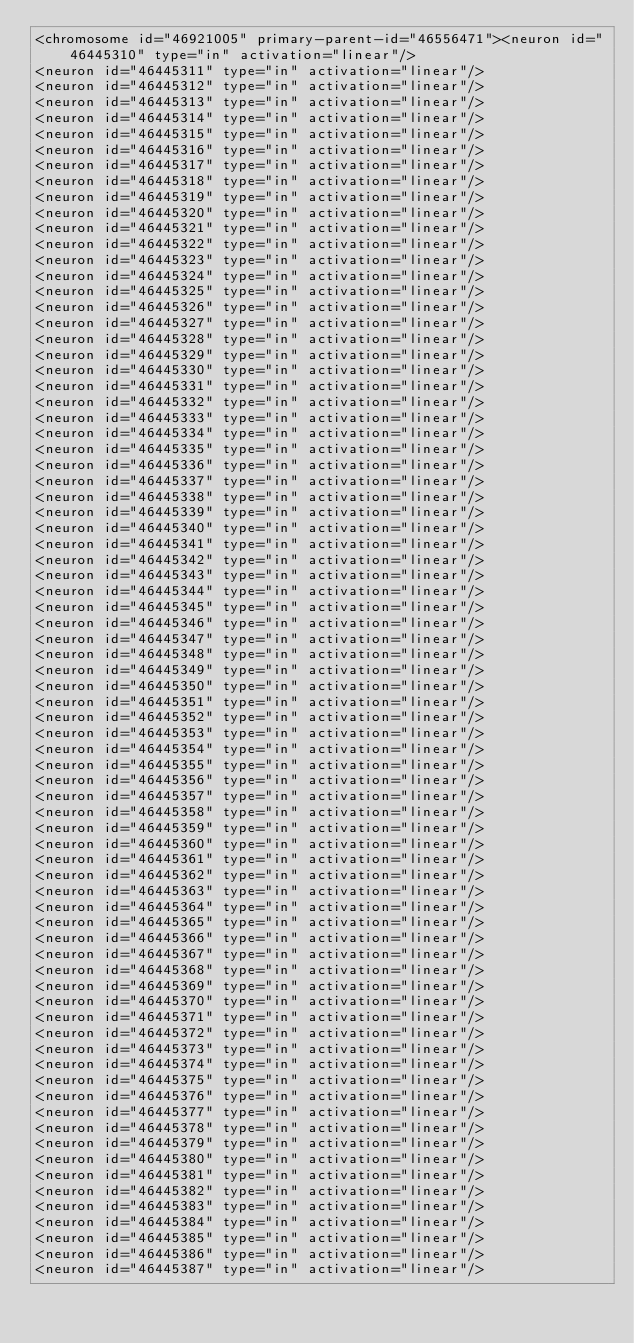Convert code to text. <code><loc_0><loc_0><loc_500><loc_500><_XML_><chromosome id="46921005" primary-parent-id="46556471"><neuron id="46445310" type="in" activation="linear"/>
<neuron id="46445311" type="in" activation="linear"/>
<neuron id="46445312" type="in" activation="linear"/>
<neuron id="46445313" type="in" activation="linear"/>
<neuron id="46445314" type="in" activation="linear"/>
<neuron id="46445315" type="in" activation="linear"/>
<neuron id="46445316" type="in" activation="linear"/>
<neuron id="46445317" type="in" activation="linear"/>
<neuron id="46445318" type="in" activation="linear"/>
<neuron id="46445319" type="in" activation="linear"/>
<neuron id="46445320" type="in" activation="linear"/>
<neuron id="46445321" type="in" activation="linear"/>
<neuron id="46445322" type="in" activation="linear"/>
<neuron id="46445323" type="in" activation="linear"/>
<neuron id="46445324" type="in" activation="linear"/>
<neuron id="46445325" type="in" activation="linear"/>
<neuron id="46445326" type="in" activation="linear"/>
<neuron id="46445327" type="in" activation="linear"/>
<neuron id="46445328" type="in" activation="linear"/>
<neuron id="46445329" type="in" activation="linear"/>
<neuron id="46445330" type="in" activation="linear"/>
<neuron id="46445331" type="in" activation="linear"/>
<neuron id="46445332" type="in" activation="linear"/>
<neuron id="46445333" type="in" activation="linear"/>
<neuron id="46445334" type="in" activation="linear"/>
<neuron id="46445335" type="in" activation="linear"/>
<neuron id="46445336" type="in" activation="linear"/>
<neuron id="46445337" type="in" activation="linear"/>
<neuron id="46445338" type="in" activation="linear"/>
<neuron id="46445339" type="in" activation="linear"/>
<neuron id="46445340" type="in" activation="linear"/>
<neuron id="46445341" type="in" activation="linear"/>
<neuron id="46445342" type="in" activation="linear"/>
<neuron id="46445343" type="in" activation="linear"/>
<neuron id="46445344" type="in" activation="linear"/>
<neuron id="46445345" type="in" activation="linear"/>
<neuron id="46445346" type="in" activation="linear"/>
<neuron id="46445347" type="in" activation="linear"/>
<neuron id="46445348" type="in" activation="linear"/>
<neuron id="46445349" type="in" activation="linear"/>
<neuron id="46445350" type="in" activation="linear"/>
<neuron id="46445351" type="in" activation="linear"/>
<neuron id="46445352" type="in" activation="linear"/>
<neuron id="46445353" type="in" activation="linear"/>
<neuron id="46445354" type="in" activation="linear"/>
<neuron id="46445355" type="in" activation="linear"/>
<neuron id="46445356" type="in" activation="linear"/>
<neuron id="46445357" type="in" activation="linear"/>
<neuron id="46445358" type="in" activation="linear"/>
<neuron id="46445359" type="in" activation="linear"/>
<neuron id="46445360" type="in" activation="linear"/>
<neuron id="46445361" type="in" activation="linear"/>
<neuron id="46445362" type="in" activation="linear"/>
<neuron id="46445363" type="in" activation="linear"/>
<neuron id="46445364" type="in" activation="linear"/>
<neuron id="46445365" type="in" activation="linear"/>
<neuron id="46445366" type="in" activation="linear"/>
<neuron id="46445367" type="in" activation="linear"/>
<neuron id="46445368" type="in" activation="linear"/>
<neuron id="46445369" type="in" activation="linear"/>
<neuron id="46445370" type="in" activation="linear"/>
<neuron id="46445371" type="in" activation="linear"/>
<neuron id="46445372" type="in" activation="linear"/>
<neuron id="46445373" type="in" activation="linear"/>
<neuron id="46445374" type="in" activation="linear"/>
<neuron id="46445375" type="in" activation="linear"/>
<neuron id="46445376" type="in" activation="linear"/>
<neuron id="46445377" type="in" activation="linear"/>
<neuron id="46445378" type="in" activation="linear"/>
<neuron id="46445379" type="in" activation="linear"/>
<neuron id="46445380" type="in" activation="linear"/>
<neuron id="46445381" type="in" activation="linear"/>
<neuron id="46445382" type="in" activation="linear"/>
<neuron id="46445383" type="in" activation="linear"/>
<neuron id="46445384" type="in" activation="linear"/>
<neuron id="46445385" type="in" activation="linear"/>
<neuron id="46445386" type="in" activation="linear"/>
<neuron id="46445387" type="in" activation="linear"/></code> 